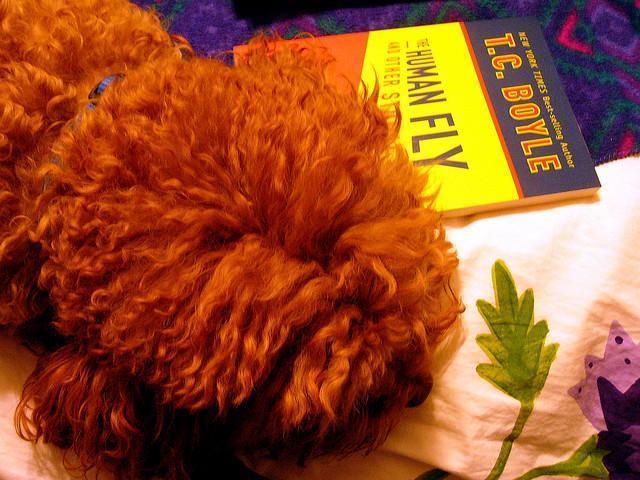How many books are shown?
Give a very brief answer. 1. 